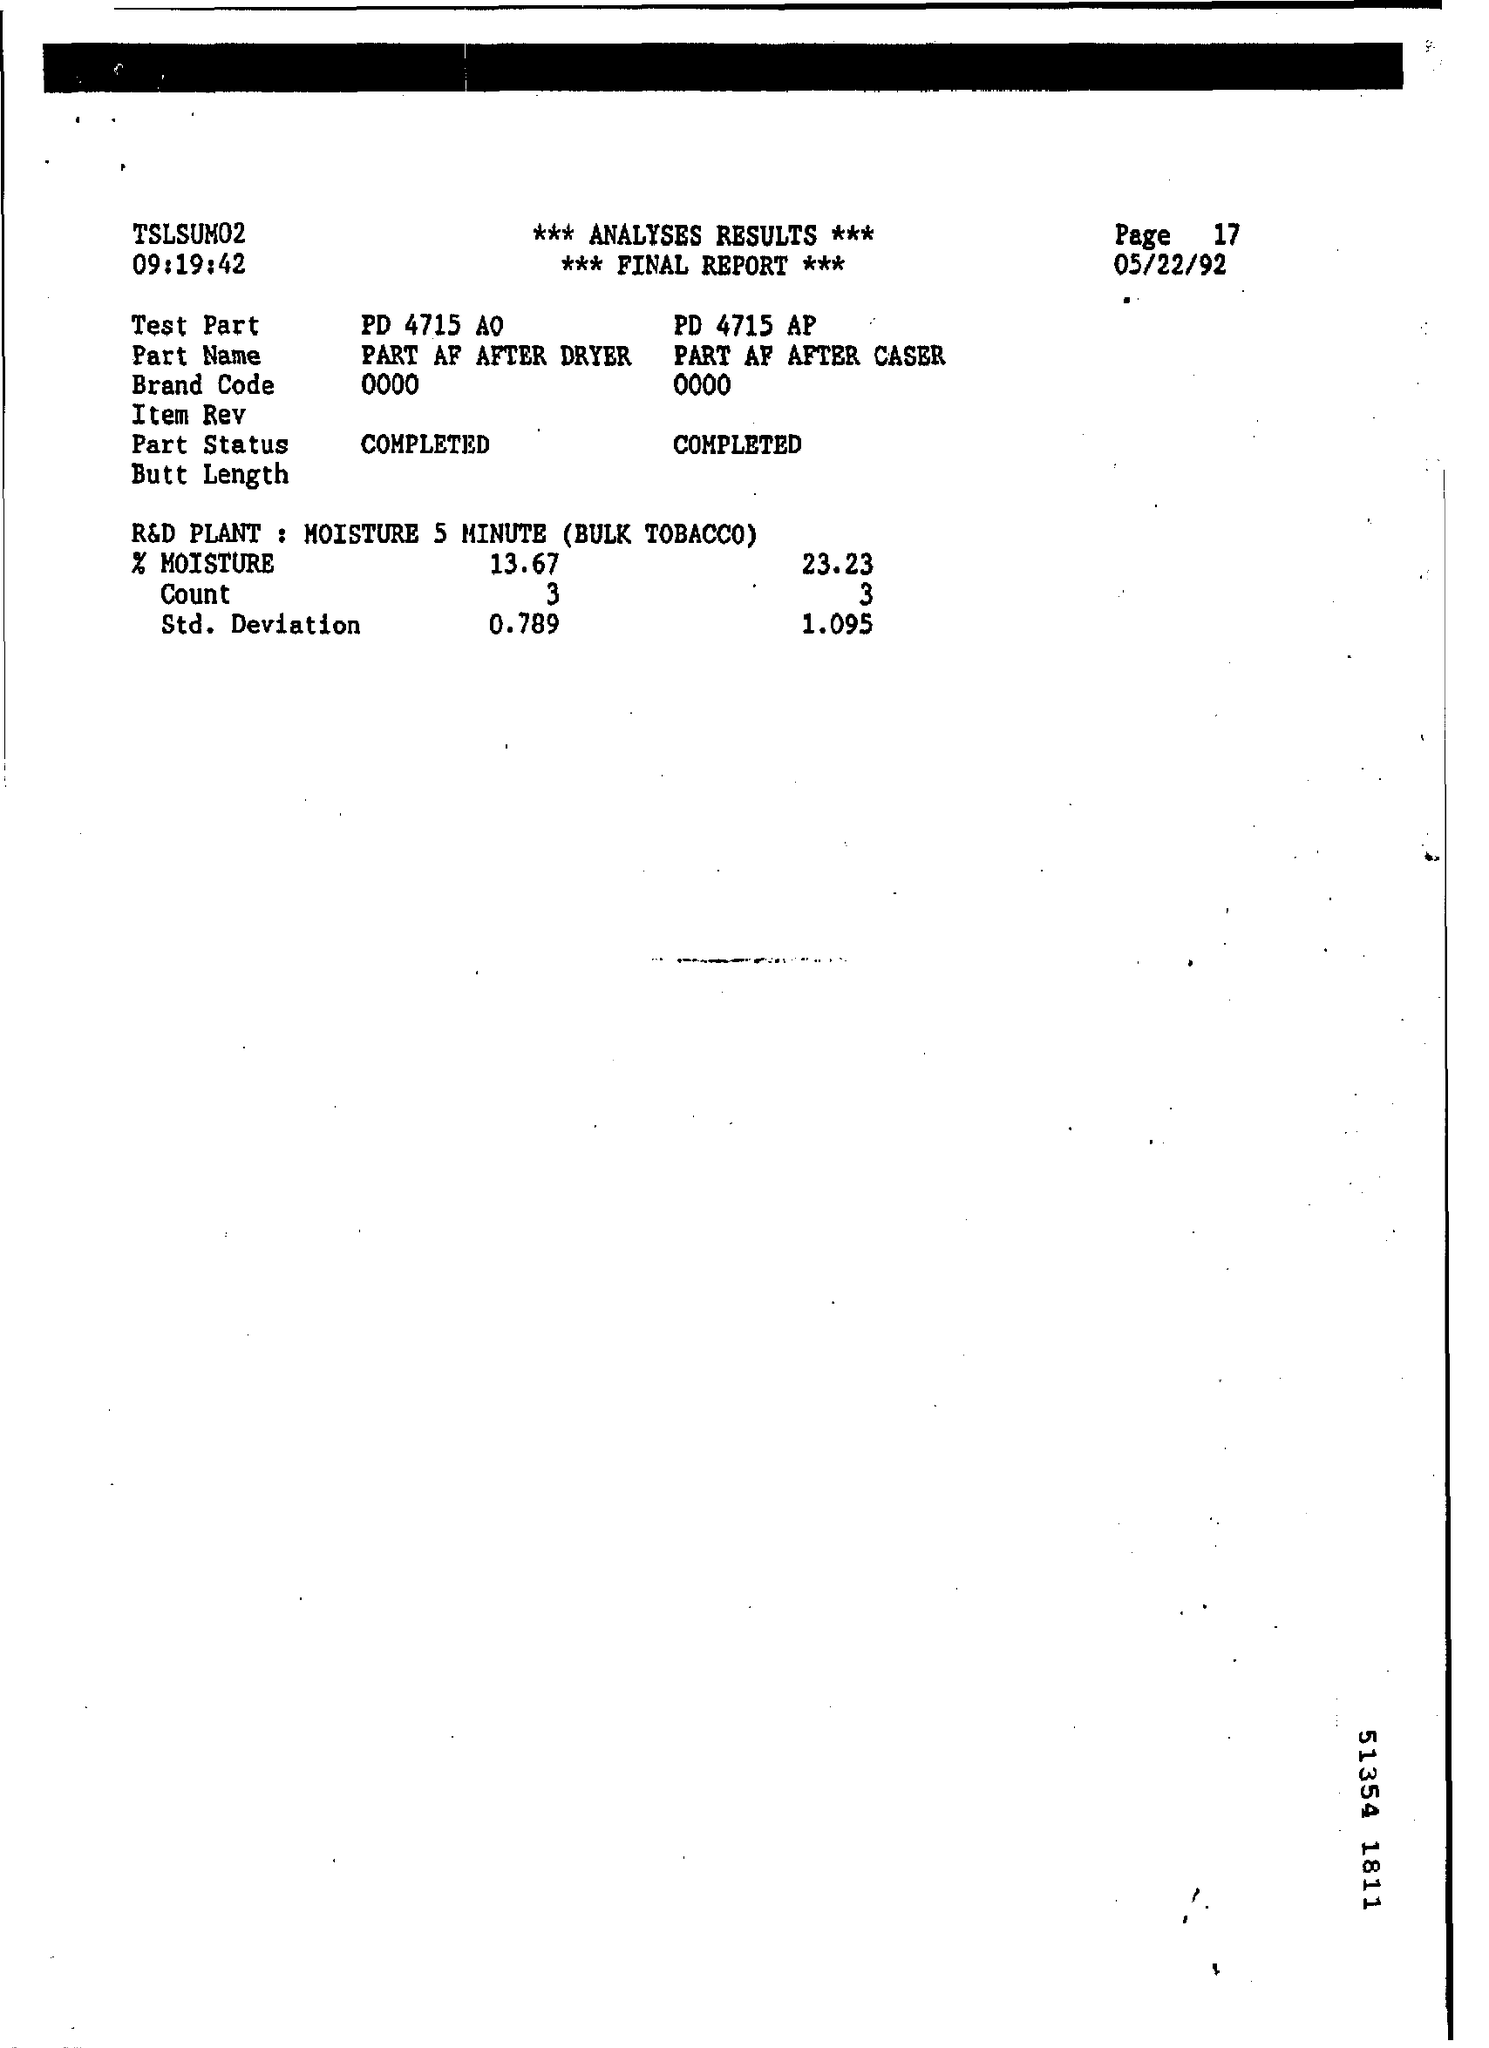What is the Page Number ?
Ensure brevity in your answer.  17. When is the Memorandum dated on ?
Offer a very short reply. 05/22/92. What is the Band Code ?
Keep it short and to the point. 0000. 